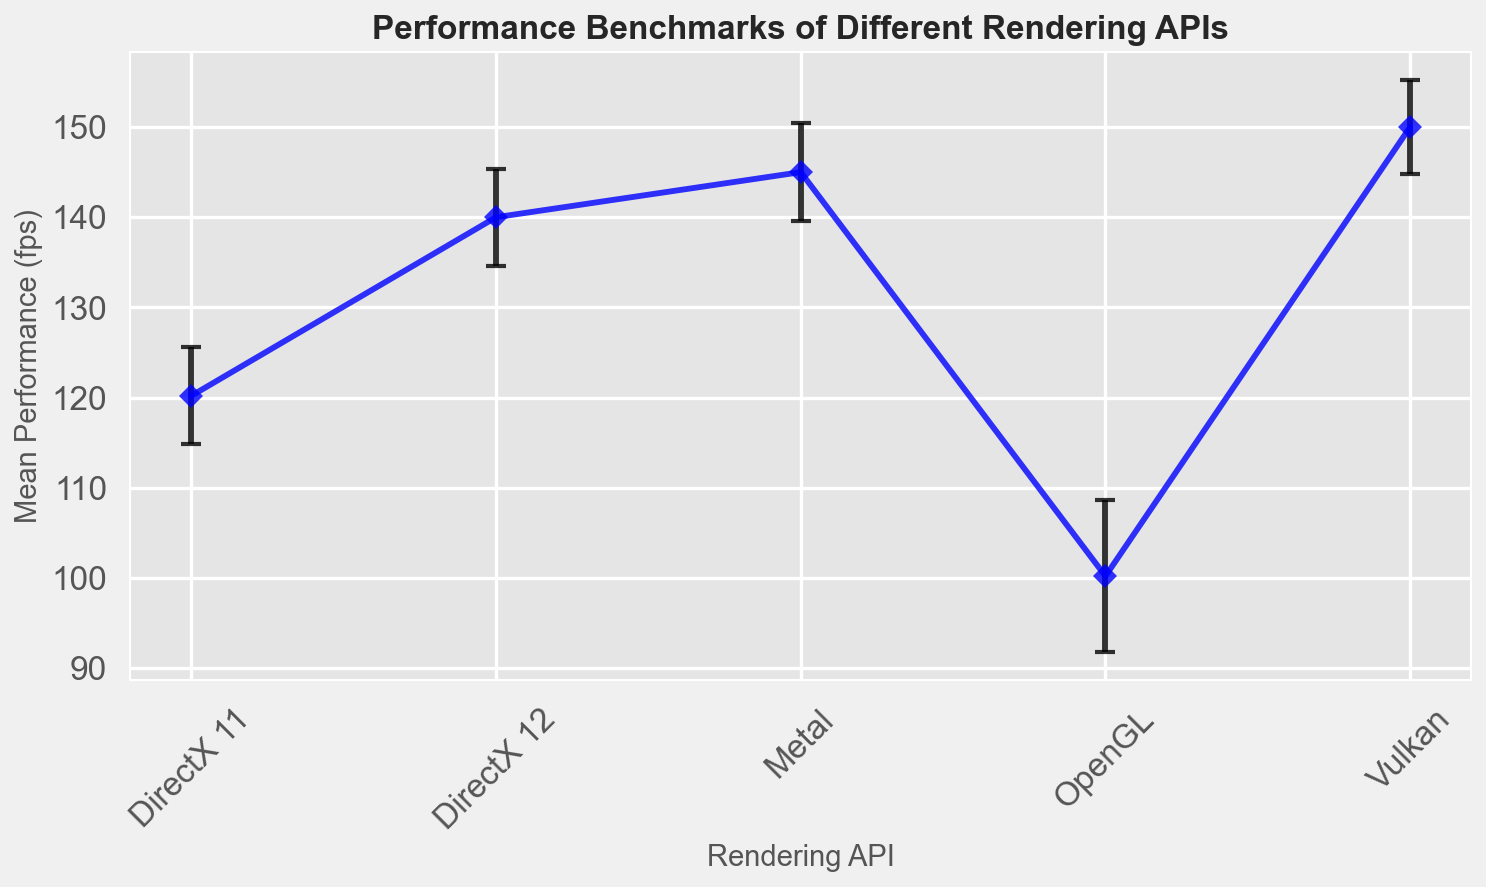Which Rendering API has the highest mean performance? By observing the graph, the highest mean performance is the one with the furthest point upwards on the y-axis. Vulkan has the highest mean performance.
Answer: Vulkan Which API has the largest error bar? The size of the error bar is indicated by the length of the vertical lines extending from the points. OpenGL has the largest error bar.
Answer: OpenGL What is the difference in mean performance between DirectX 12 and Metal? Locate the mean performance values for DirectX 12 and Metal on the graph. DirectX 12 is around 140 fps, and Metal is around 145 fps. The difference is 145 - 140 = 5 fps.
Answer: 5 fps Which Rendering API has the smallest variability in performance? The smallest variability is represented by the shortest error bars. Vulkan has the shortest error bars, indicating the smallest variability.
Answer: Vulkan What is the approximate range of performance for OpenGL? The range can be estimated by adding and subtracting the error (standard deviation) from the mean value. OpenGL mean performance is around 100 fps with an error of approximately 8 fps. So, the range is 100 ± 8, or 92 to 108 fps.
Answer: 92 to 108 fps Compare the mean performances of DirectX 11 and Vulkan. Locate the mean performance points for DirectX 11 and Vulkan on the graph. DirectX 11 has a mean of around 120 fps, and Vulkan has a mean of around 150 fps. Vulkan has a higher mean performance compared to DirectX 11.
Answer: Vulkan is higher Which API has the most consistent performance, and what is its standard deviation? The most consistent performance is indicated by the shortest error bars. Vulkan shows the most consistent performance. The error bar, representing the standard deviation, is around 5 fps.
Answer: Vulkan, 5 fps How much higher is the mean performance of Metal compared to OpenGL? Find the mean performance values for Metal and OpenGL. Metal is at approximately 145 fps, and OpenGL is at approximately 100 fps. The difference is 145 - 100 = 45 fps.
Answer: 45 fps Among the APIs, which one has mean performance closest to 140 fps? Identify the API whose mean performance is closest to 140 fps. DirectX 12 has a mean performance of approximately 140 fps.
Answer: DirectX 12 